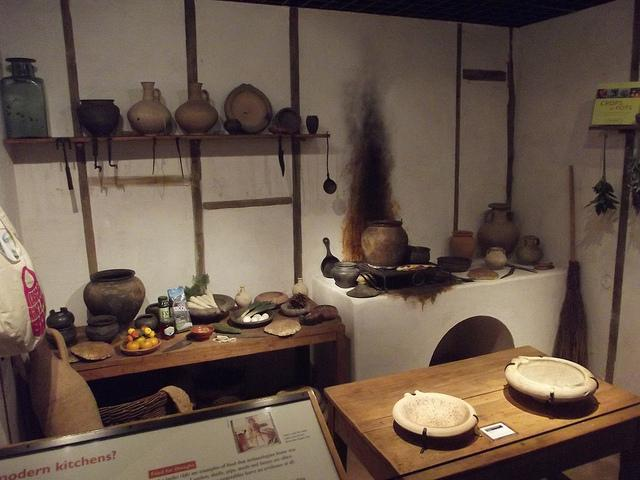In what type building is this located? Please explain your reasoning. museum. The room has some old items inside. 